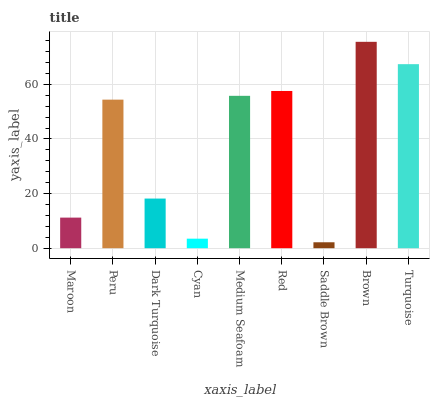Is Peru the minimum?
Answer yes or no. No. Is Peru the maximum?
Answer yes or no. No. Is Peru greater than Maroon?
Answer yes or no. Yes. Is Maroon less than Peru?
Answer yes or no. Yes. Is Maroon greater than Peru?
Answer yes or no. No. Is Peru less than Maroon?
Answer yes or no. No. Is Peru the high median?
Answer yes or no. Yes. Is Peru the low median?
Answer yes or no. Yes. Is Brown the high median?
Answer yes or no. No. Is Turquoise the low median?
Answer yes or no. No. 